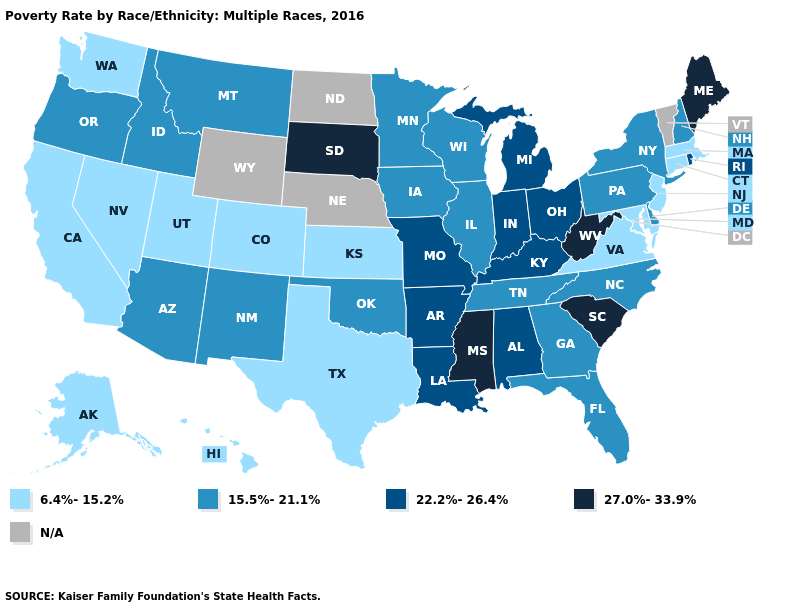Does the first symbol in the legend represent the smallest category?
Keep it brief. Yes. What is the lowest value in the MidWest?
Be succinct. 6.4%-15.2%. What is the value of Arizona?
Write a very short answer. 15.5%-21.1%. Name the states that have a value in the range N/A?
Write a very short answer. Nebraska, North Dakota, Vermont, Wyoming. Which states have the lowest value in the West?
Quick response, please. Alaska, California, Colorado, Hawaii, Nevada, Utah, Washington. Name the states that have a value in the range 27.0%-33.9%?
Write a very short answer. Maine, Mississippi, South Carolina, South Dakota, West Virginia. What is the lowest value in the USA?
Short answer required. 6.4%-15.2%. What is the value of North Dakota?
Quick response, please. N/A. What is the value of Massachusetts?
Concise answer only. 6.4%-15.2%. Among the states that border Pennsylvania , which have the highest value?
Quick response, please. West Virginia. Name the states that have a value in the range N/A?
Answer briefly. Nebraska, North Dakota, Vermont, Wyoming. What is the value of Kentucky?
Write a very short answer. 22.2%-26.4%. 